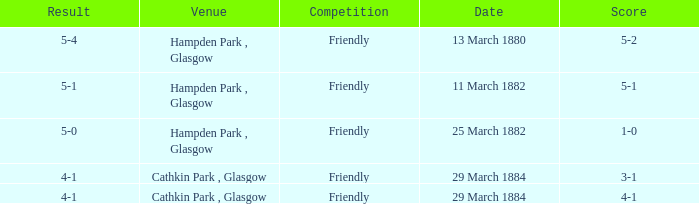Write the full table. {'header': ['Result', 'Venue', 'Competition', 'Date', 'Score'], 'rows': [['5-4', 'Hampden Park , Glasgow', 'Friendly', '13 March 1880', '5-2'], ['5-1', 'Hampden Park , Glasgow', 'Friendly', '11 March 1882', '5-1'], ['5-0', 'Hampden Park , Glasgow', 'Friendly', '25 March 1882', '1-0'], ['4-1', 'Cathkin Park , Glasgow', 'Friendly', '29 March 1884', '3-1'], ['4-1', 'Cathkin Park , Glasgow', 'Friendly', '29 March 1884', '4-1']]} Which item has a score of 5-1? 5-1. 